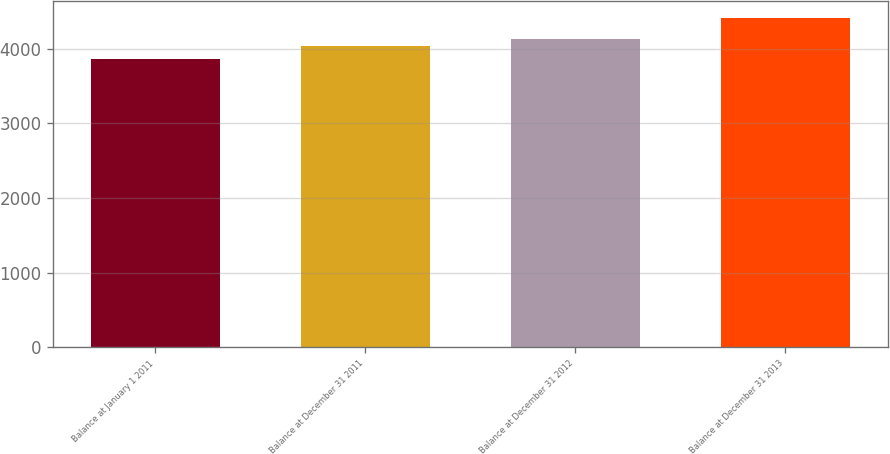Convert chart. <chart><loc_0><loc_0><loc_500><loc_500><bar_chart><fcel>Balance at January 1 2011<fcel>Balance at December 31 2011<fcel>Balance at December 31 2012<fcel>Balance at December 31 2013<nl><fcel>3866<fcel>4033<fcel>4122<fcel>4415<nl></chart> 